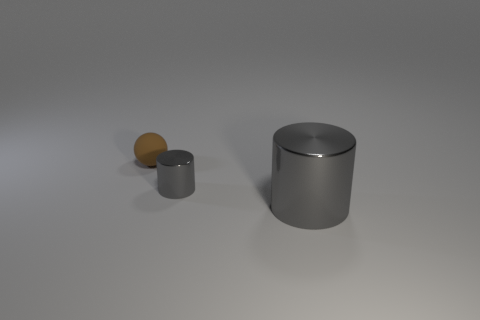There is another thing that is the same shape as the large thing; what is it made of?
Offer a terse response. Metal. How many other objects are the same color as the tiny rubber sphere?
Provide a short and direct response. 0. There is a small metal object; is it the same color as the small thing behind the small gray thing?
Offer a very short reply. No. There is a metal thing to the right of the tiny cylinder; how many cylinders are behind it?
Your answer should be compact. 1. Is there any other thing that has the same material as the tiny brown object?
Your answer should be very brief. No. There is a small thing that is in front of the object that is behind the small object in front of the tiny matte object; what is its material?
Offer a terse response. Metal. What material is the thing that is both behind the large gray metallic cylinder and right of the brown thing?
Your answer should be very brief. Metal. How many other brown matte objects are the same shape as the tiny matte thing?
Provide a succinct answer. 0. There is a thing that is right of the tiny thing in front of the tiny matte object; what is its size?
Offer a terse response. Large. Do the small object in front of the small ball and the matte object that is left of the big metallic cylinder have the same color?
Provide a short and direct response. No. 